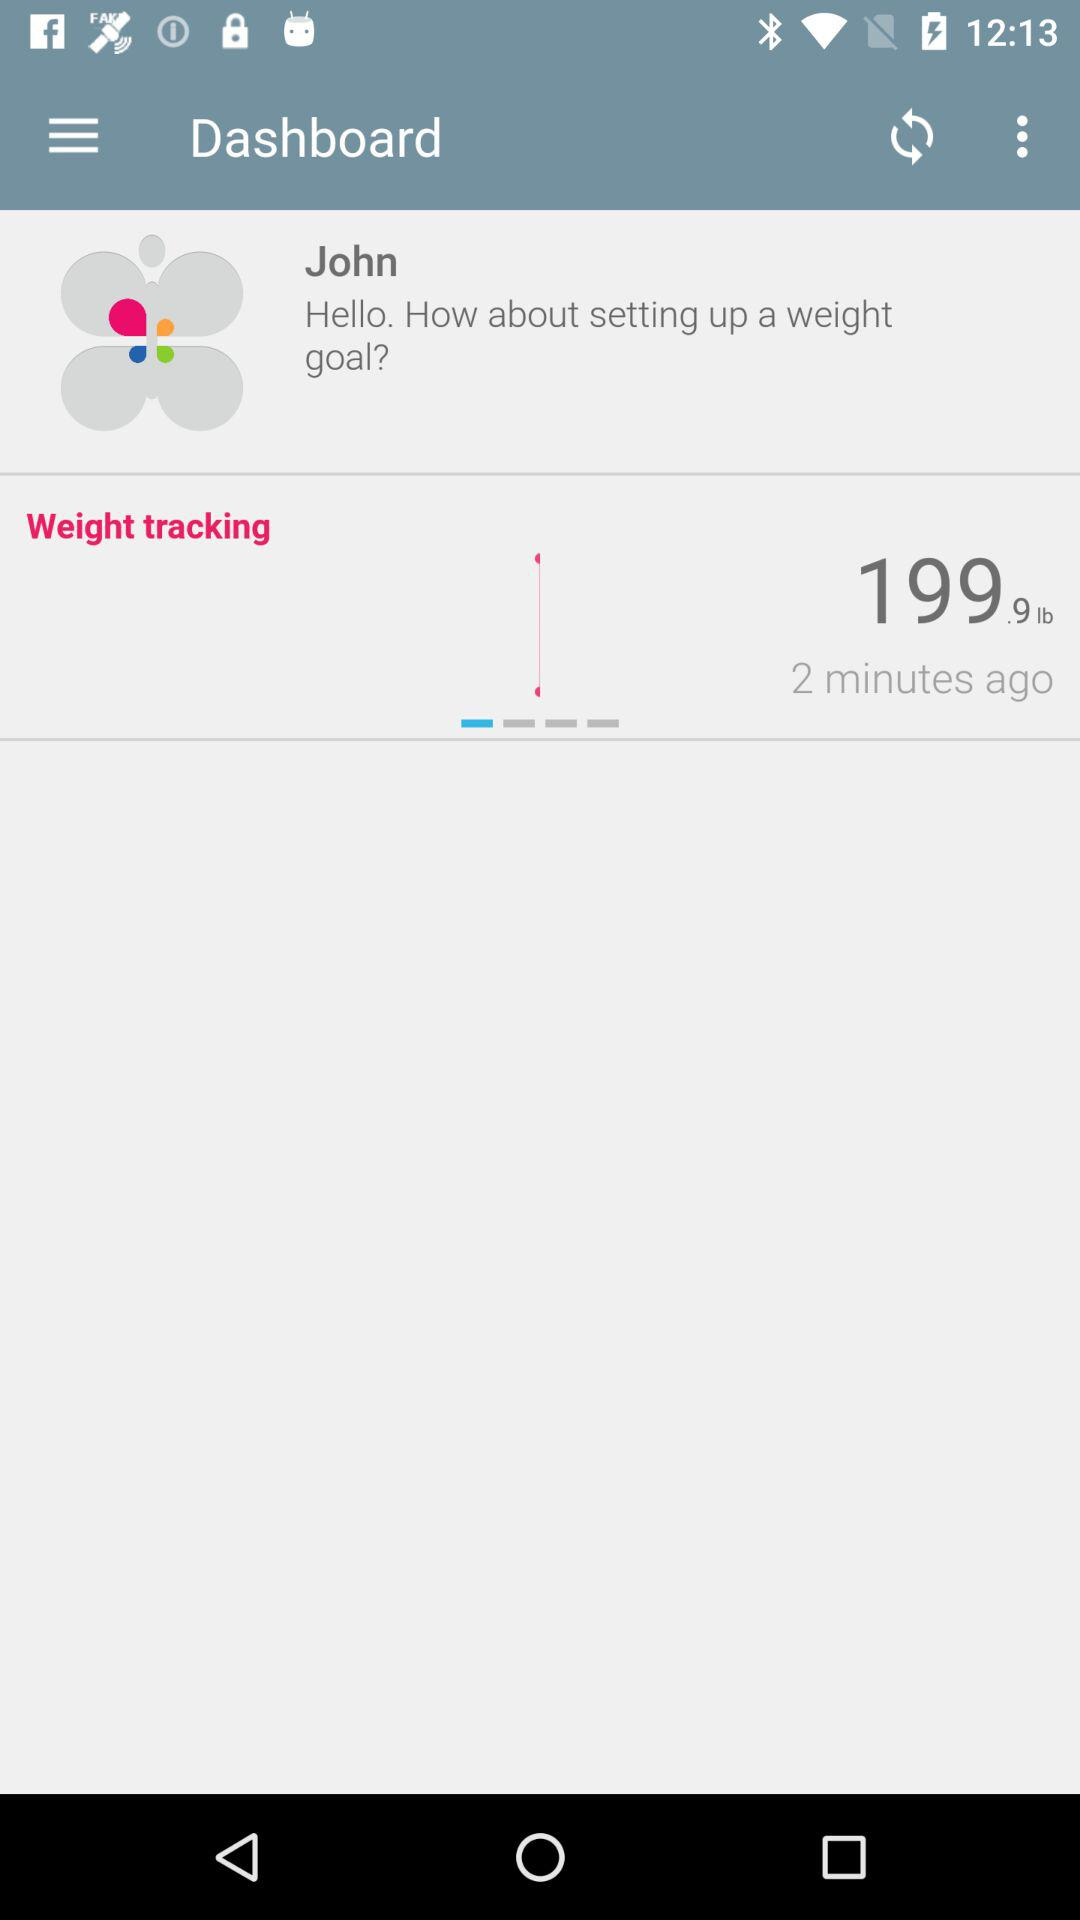When was the weight in "Weight tracking" updated? It was updated 2 minutes ago. 